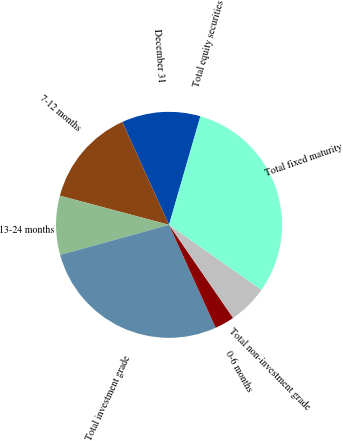Convert chart. <chart><loc_0><loc_0><loc_500><loc_500><pie_chart><fcel>December 31<fcel>7-12 months<fcel>13-24 months<fcel>Total investment grade<fcel>0-6 months<fcel>Total non-investment grade<fcel>Total fixed maturity<fcel>Total equity securities<nl><fcel>11.25%<fcel>14.06%<fcel>8.45%<fcel>27.47%<fcel>2.83%<fcel>5.64%<fcel>30.28%<fcel>0.02%<nl></chart> 